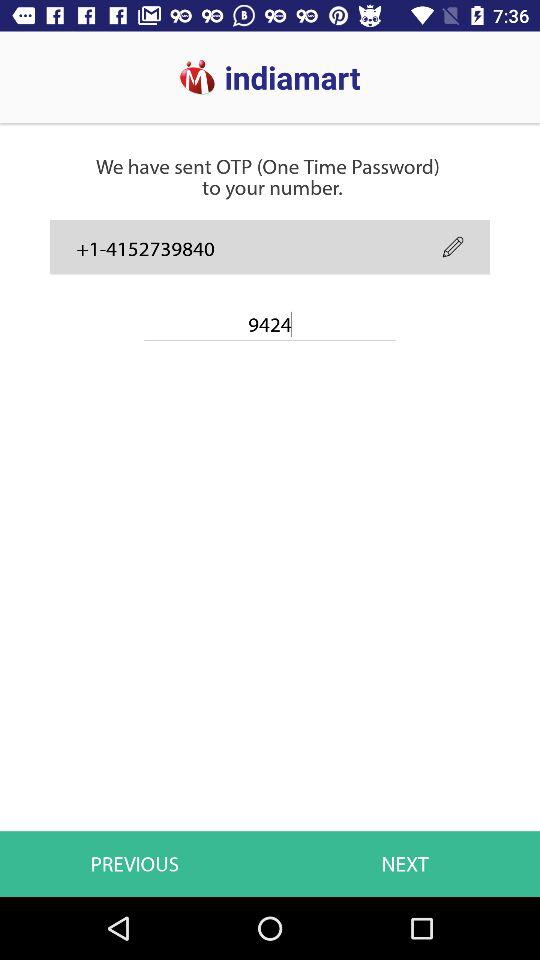How many digits are there in the OTP number?
Answer the question using a single word or phrase. 4 